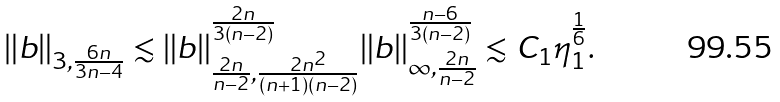<formula> <loc_0><loc_0><loc_500><loc_500>\| b \| _ { 3 , \frac { 6 n } { 3 n - 4 } } \lesssim \| b \| _ { \frac { 2 n } { n - 2 } , \frac { 2 n ^ { 2 } } { ( n + 1 ) ( n - 2 ) } } ^ { \frac { 2 n } { 3 ( n - 2 ) } } \| b \| _ { \infty , \frac { 2 n } { n - 2 } } ^ { \frac { n - 6 } { 3 ( n - 2 ) } } \lesssim C _ { 1 } \eta _ { 1 } ^ { \frac { 1 } { 6 } } .</formula> 